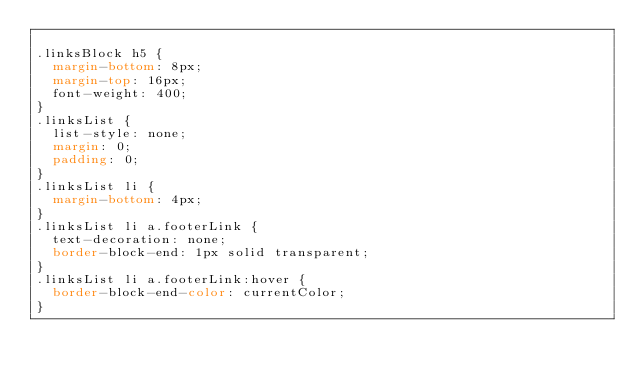<code> <loc_0><loc_0><loc_500><loc_500><_CSS_>
.linksBlock h5 {
  margin-bottom: 8px;
  margin-top: 16px;
  font-weight: 400;
}
.linksList {
  list-style: none;
  margin: 0;
  padding: 0;
}
.linksList li {
  margin-bottom: 4px;
}
.linksList li a.footerLink {
  text-decoration: none;
  border-block-end: 1px solid transparent;
}
.linksList li a.footerLink:hover {
  border-block-end-color: currentColor;
}
</code> 